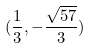Convert formula to latex. <formula><loc_0><loc_0><loc_500><loc_500>( \frac { 1 } { 3 } , - \frac { \sqrt { 5 7 } } { 3 } )</formula> 